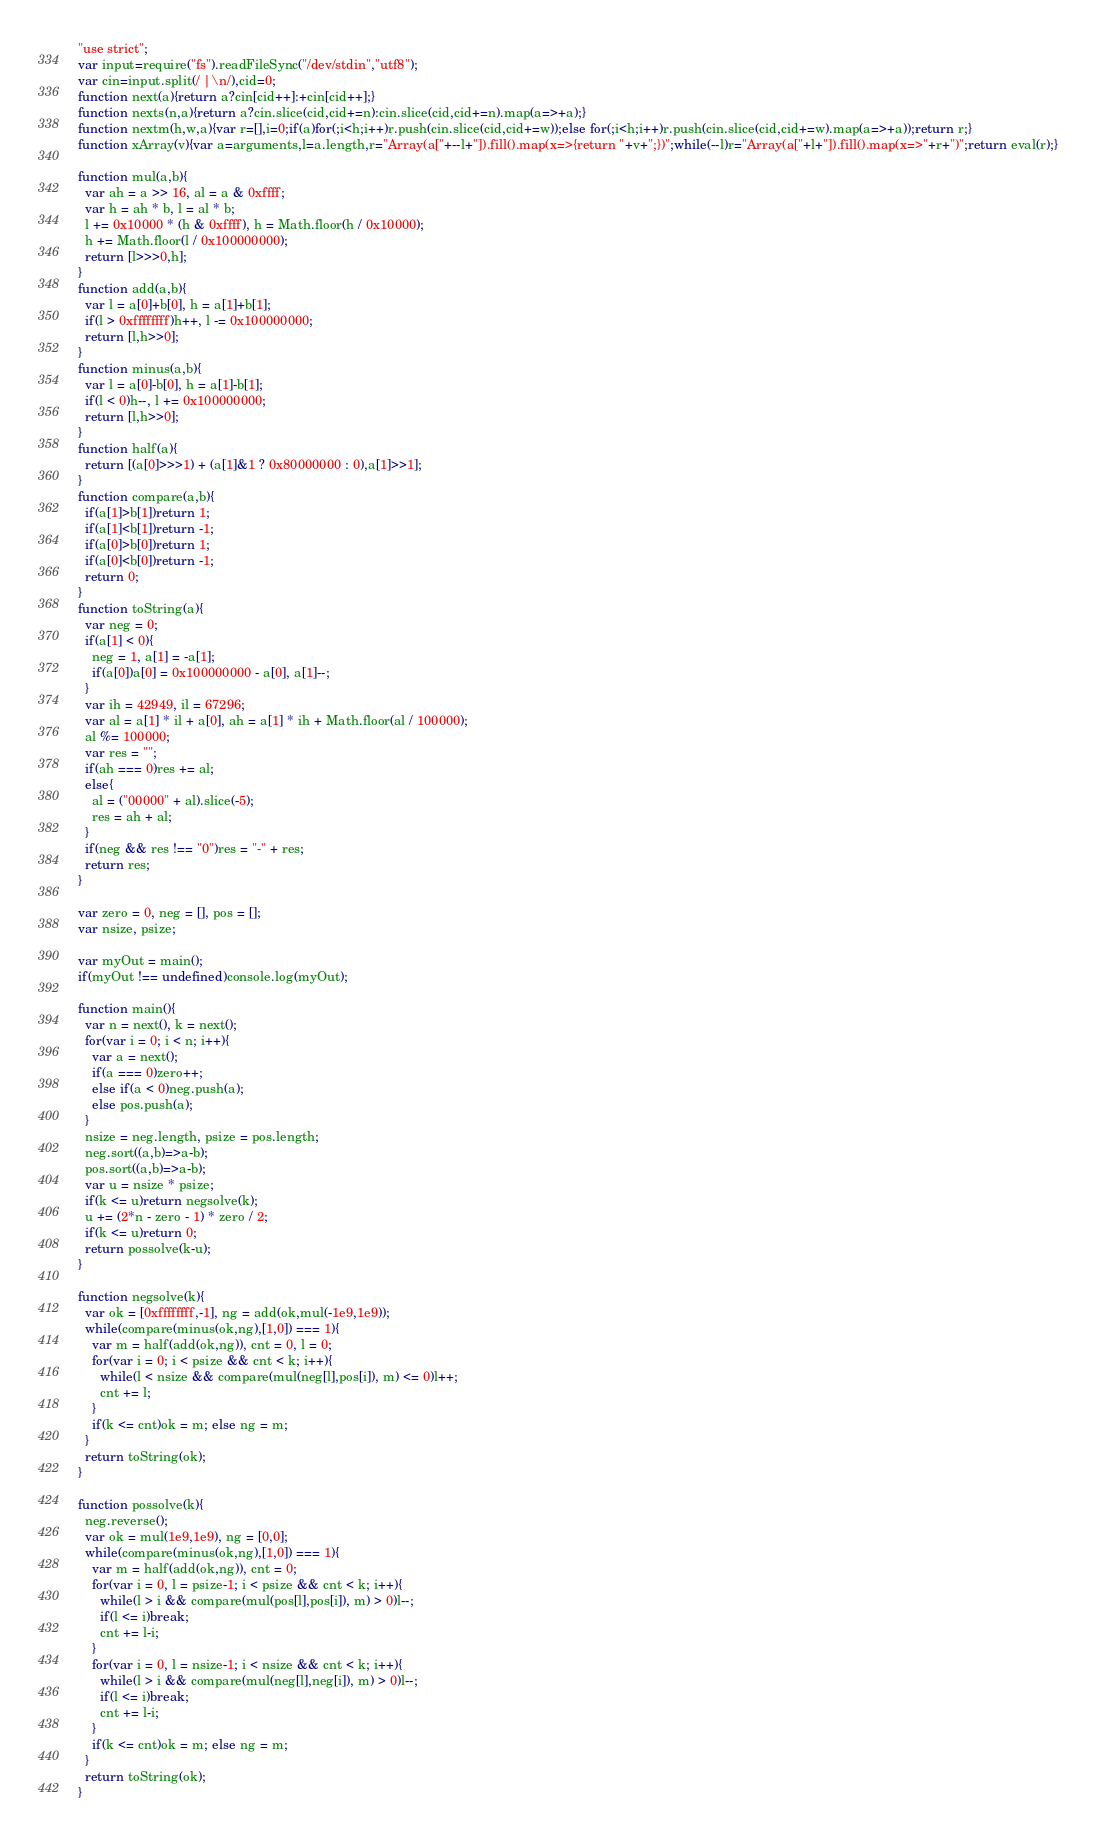Convert code to text. <code><loc_0><loc_0><loc_500><loc_500><_JavaScript_>"use strict";
var input=require("fs").readFileSync("/dev/stdin","utf8");
var cin=input.split(/ |\n/),cid=0;
function next(a){return a?cin[cid++]:+cin[cid++];}
function nexts(n,a){return a?cin.slice(cid,cid+=n):cin.slice(cid,cid+=n).map(a=>+a);}
function nextm(h,w,a){var r=[],i=0;if(a)for(;i<h;i++)r.push(cin.slice(cid,cid+=w));else for(;i<h;i++)r.push(cin.slice(cid,cid+=w).map(a=>+a));return r;}
function xArray(v){var a=arguments,l=a.length,r="Array(a["+--l+"]).fill().map(x=>{return "+v+";})";while(--l)r="Array(a["+l+"]).fill().map(x=>"+r+")";return eval(r);}

function mul(a,b){
  var ah = a >> 16, al = a & 0xffff;
  var h = ah * b, l = al * b;
  l += 0x10000 * (h & 0xffff), h = Math.floor(h / 0x10000);
  h += Math.floor(l / 0x100000000);
  return [l>>>0,h];
}
function add(a,b){
  var l = a[0]+b[0], h = a[1]+b[1];
  if(l > 0xffffffff)h++, l -= 0x100000000;
  return [l,h>>0];
}
function minus(a,b){
  var l = a[0]-b[0], h = a[1]-b[1];
  if(l < 0)h--, l += 0x100000000;
  return [l,h>>0];
}
function half(a){
  return [(a[0]>>>1) + (a[1]&1 ? 0x80000000 : 0),a[1]>>1];
}
function compare(a,b){
  if(a[1]>b[1])return 1;
  if(a[1]<b[1])return -1;
  if(a[0]>b[0])return 1;
  if(a[0]<b[0])return -1;
  return 0;
}
function toString(a){
  var neg = 0;
  if(a[1] < 0){
    neg = 1, a[1] = -a[1];
    if(a[0])a[0] = 0x100000000 - a[0], a[1]--;
  }
  var ih = 42949, il = 67296;
  var al = a[1] * il + a[0], ah = a[1] * ih + Math.floor(al / 100000);
  al %= 100000;
  var res = "";
  if(ah === 0)res += al;
  else{
    al = ("00000" + al).slice(-5);
    res = ah + al;
  }
  if(neg && res !== "0")res = "-" + res;
  return res;
}

var zero = 0, neg = [], pos = [];
var nsize, psize;

var myOut = main();
if(myOut !== undefined)console.log(myOut);

function main(){
  var n = next(), k = next();
  for(var i = 0; i < n; i++){
    var a = next();
    if(a === 0)zero++;
    else if(a < 0)neg.push(a);
    else pos.push(a);
  }
  nsize = neg.length, psize = pos.length;
  neg.sort((a,b)=>a-b);
  pos.sort((a,b)=>a-b);
  var u = nsize * psize;
  if(k <= u)return negsolve(k);
  u += (2*n - zero - 1) * zero / 2;
  if(k <= u)return 0;
  return possolve(k-u);
}

function negsolve(k){
  var ok = [0xffffffff,-1], ng = add(ok,mul(-1e9,1e9));
  while(compare(minus(ok,ng),[1,0]) === 1){
    var m = half(add(ok,ng)), cnt = 0, l = 0;
    for(var i = 0; i < psize && cnt < k; i++){
      while(l < nsize && compare(mul(neg[l],pos[i]), m) <= 0)l++;
      cnt += l;
    }
    if(k <= cnt)ok = m; else ng = m;
  }
  return toString(ok);
}

function possolve(k){
  neg.reverse();
  var ok = mul(1e9,1e9), ng = [0,0];
  while(compare(minus(ok,ng),[1,0]) === 1){
    var m = half(add(ok,ng)), cnt = 0;
    for(var i = 0, l = psize-1; i < psize && cnt < k; i++){
      while(l > i && compare(mul(pos[l],pos[i]), m) > 0)l--;
      if(l <= i)break;
      cnt += l-i;
    }
    for(var i = 0, l = nsize-1; i < nsize && cnt < k; i++){
      while(l > i && compare(mul(neg[l],neg[i]), m) > 0)l--;
      if(l <= i)break;
      cnt += l-i;
    }
    if(k <= cnt)ok = m; else ng = m;
  }
  return toString(ok);
}</code> 